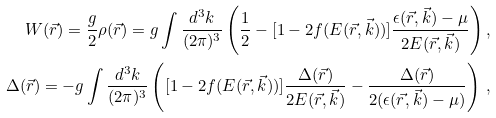Convert formula to latex. <formula><loc_0><loc_0><loc_500><loc_500>W ( \vec { r } ) = \frac { g } { 2 } \rho ( \vec { r } ) = g \int \frac { d ^ { 3 } k } { ( 2 \pi ) ^ { 3 } } \left ( \frac { 1 } { 2 } - [ 1 - 2 f ( E ( \vec { r } , \vec { k } ) ) ] \frac { \epsilon ( \vec { r } , \vec { k } ) - \mu } { 2 E ( \vec { r } , \vec { k } ) } \right ) , \\ \Delta ( \vec { r } ) = - g \int \frac { d ^ { 3 } k } { ( 2 \pi ) ^ { 3 } } \left ( [ 1 - 2 f ( E ( \vec { r } , \vec { k } ) ) ] \frac { \Delta ( \vec { r } ) } { 2 E ( \vec { r } , \vec { k } ) } - \frac { \Delta ( \vec { r } ) } { 2 ( \epsilon ( \vec { r } , \vec { k } ) - \mu ) } \right ) \, ,</formula> 